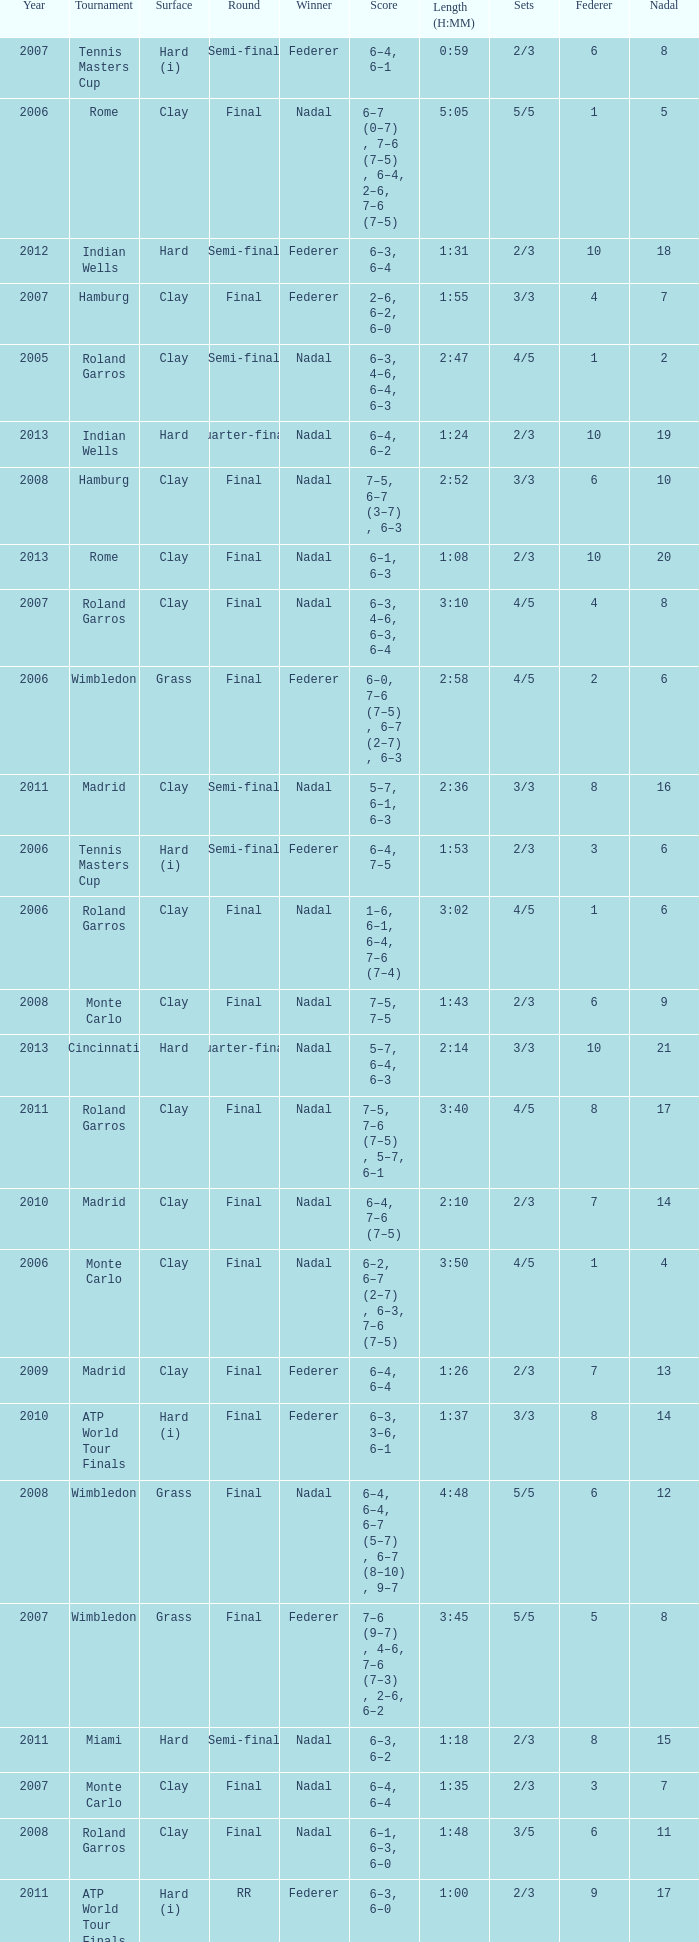What tournament did Nadal win and had a nadal of 16? Madrid. 